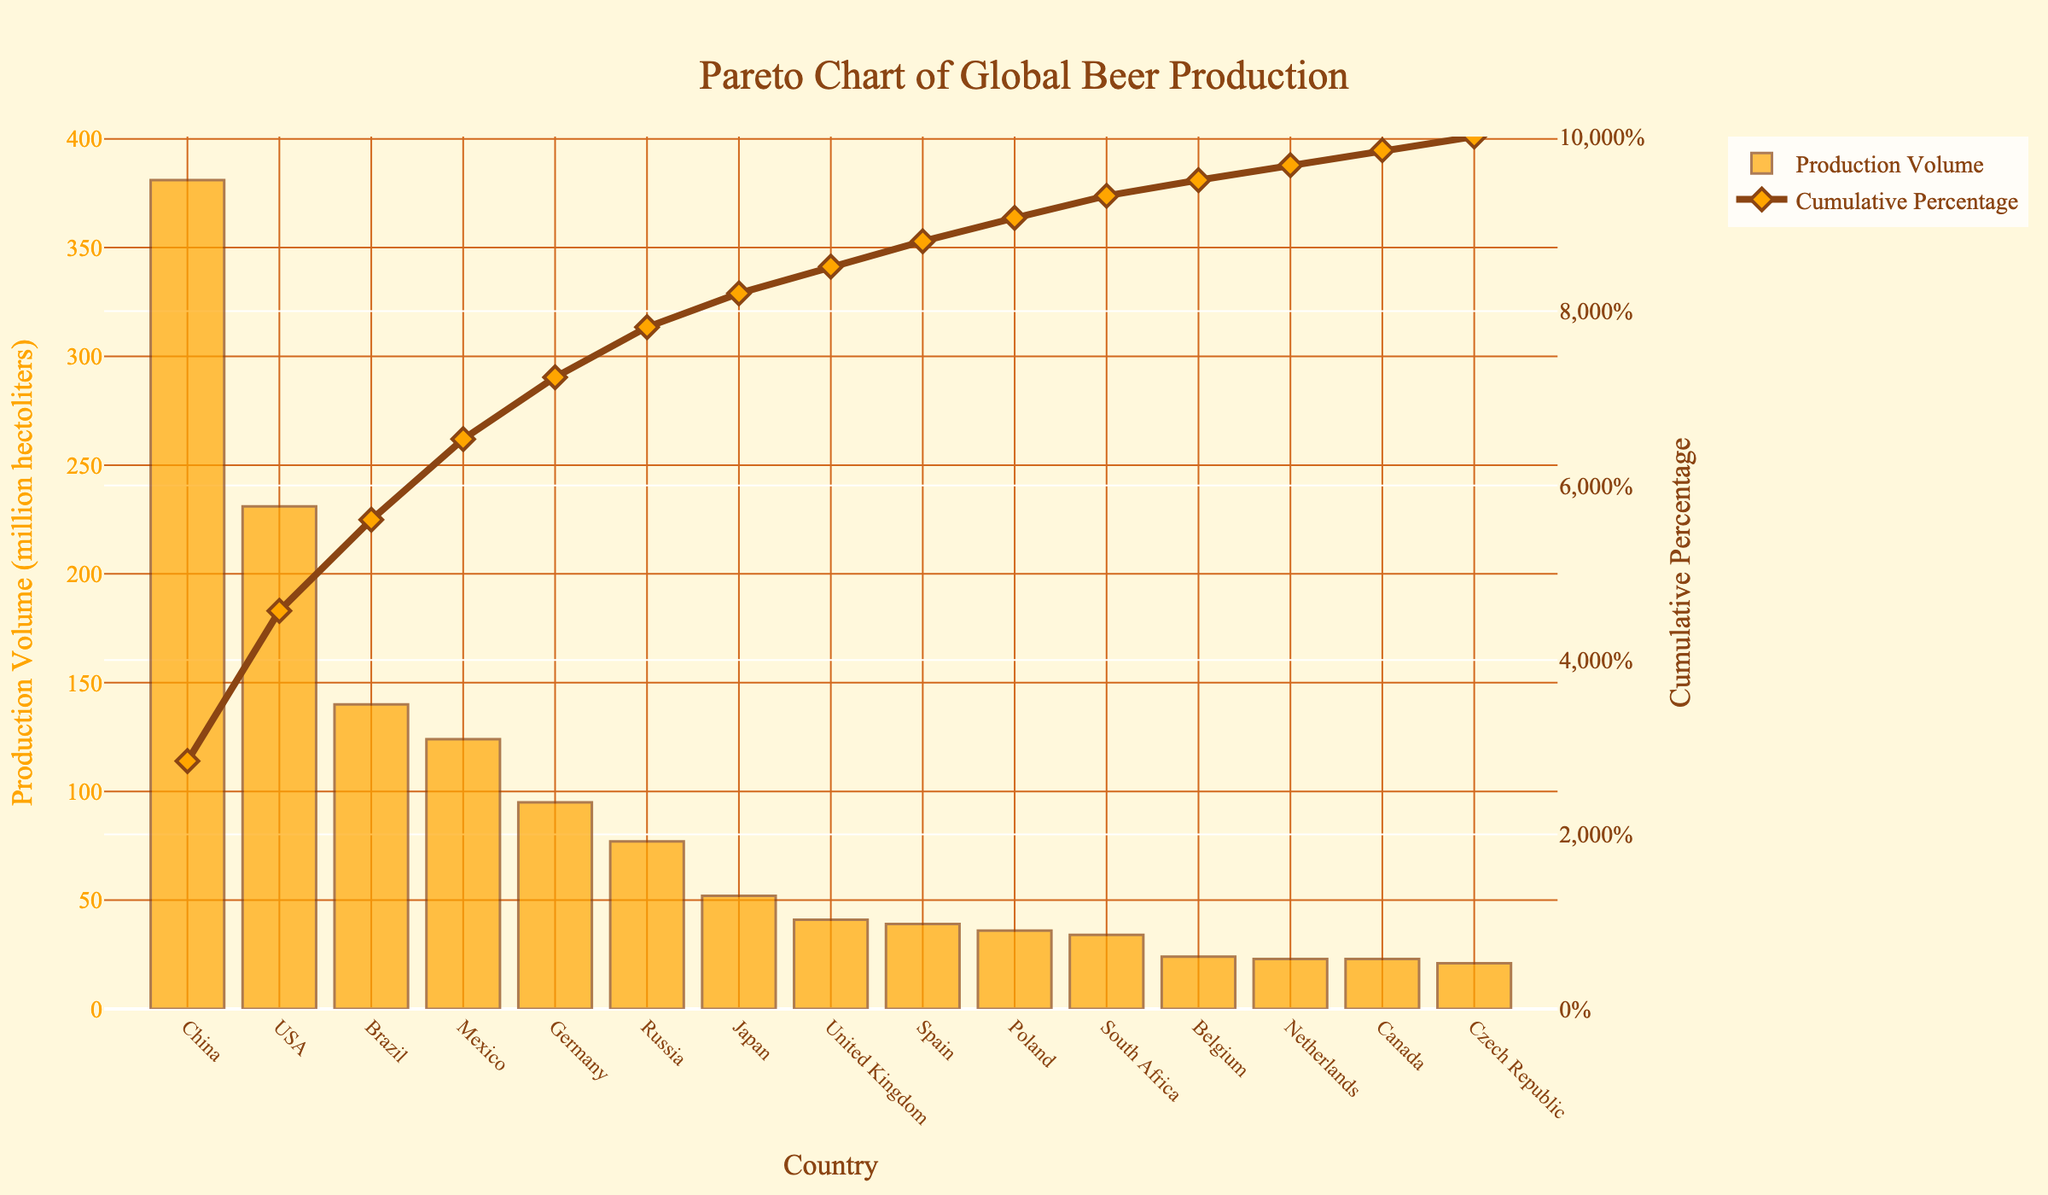What's the title of the figure? The title is typically located at the top or center of a figure and is meant to provide a brief description of what the figure represents.
Answer: Pareto Chart of Global Beer Production How many countries are represented in the chart? By counting the x-axis labels, each representing a country, you can determine the number of countries.
Answer: 15 Which country has the highest beer production volume? The country with the tallest bar in the bar chart portion of the Pareto chart indicates the highest beer production volume.
Answer: China What's the beer production volume of the USA? Locate the bar labeled "USA" on the x-axis and read the height of the bar against the left y-axis.
Answer: 231 million hectoliters What cumulative percentage does China contribute to beer production? Follow the line chart or the secondary y-axis value next to the country "China" on the x-axis to find the cumulative percentage.
Answer: Approximately 21.8% What's the total beer production volume of Brazil and Mexico combined? Identify the heights of the bars for Brazil and Mexico and add their production volumes: Brazil (140 million hectoliters) + Mexico (124 million hectoliters).
Answer: 264 million hectoliters What’s the difference in beer production volume between Germany and Russia? Subtract the production volume of Russia from that of Germany: Germany (95 million hectoliters) - Russia (77 million hectoliters).
Answer: 18 million hectoliters Which country shows a cumulative percentage of around 50%? Look for the point where the cumulative percentage line chart crosses 50% on the secondary y-axis, then trace down vertically to the corresponding country on the x-axis.
Answer: USA How does the beer production volume of Spain compare to that of Poland? Compare the heights of the bars for Spain and Poland; Spain is just slightly taller than Poland.
Answer: Spain is slightly higher than Poland At what cumulative percentage does the beer production volume of the top three countries (China, USA, Brazil) reach? Add up the production volumes of China, USA, and Brazil, then refer to the cumulative percentage line to see where these three countries’ production intersects: (381 + 231 + 140) million hectoliters, which should be close to 50%.
Answer: Approximately 60% 